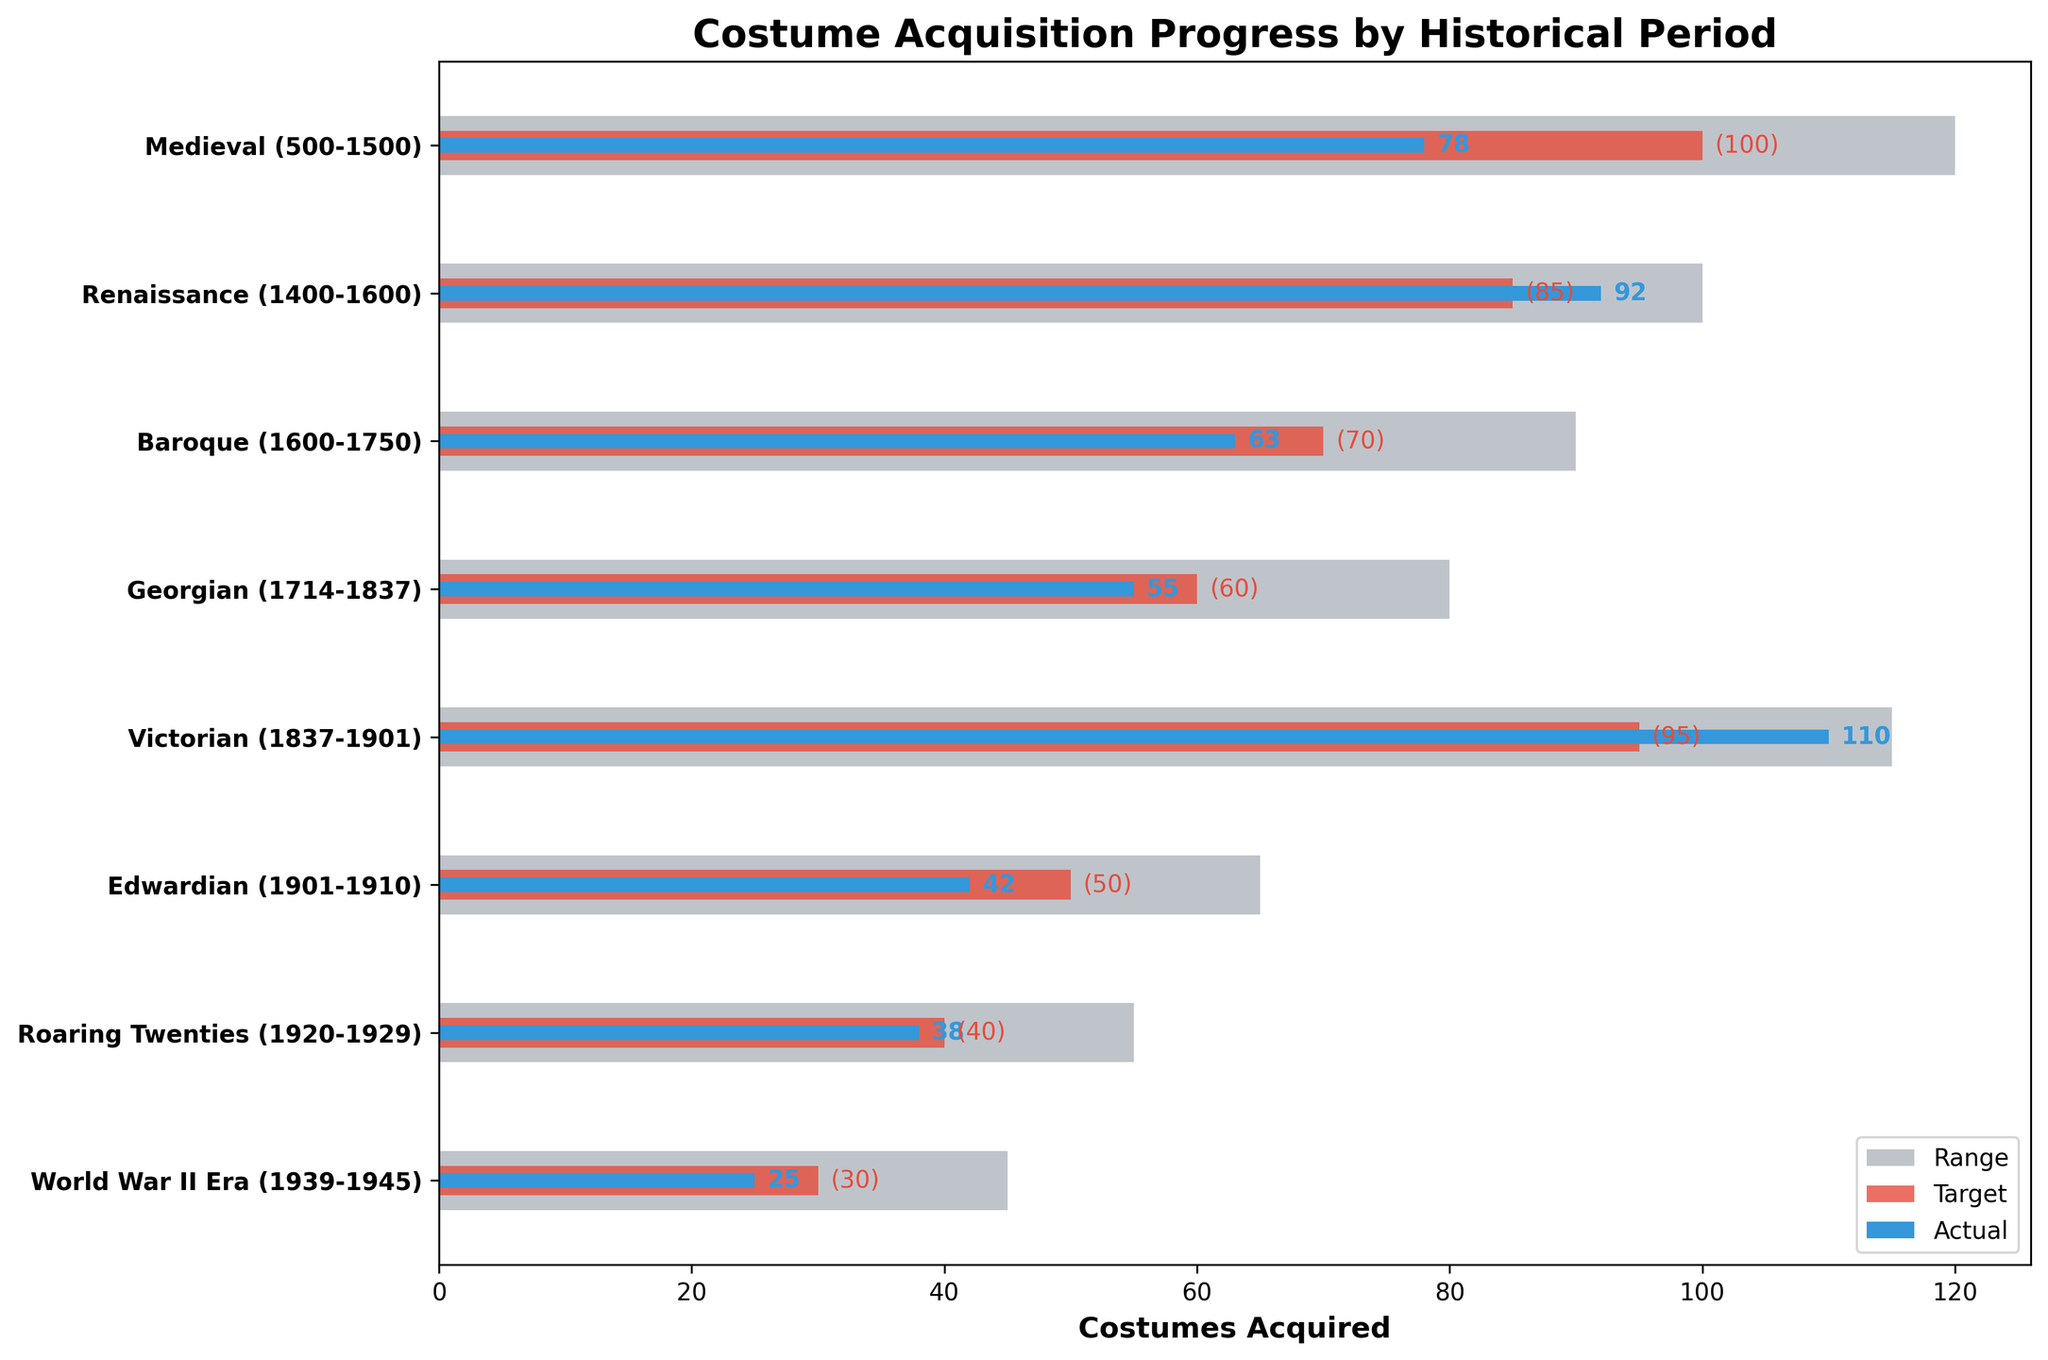What is the title of the figure? The title of the figure is displayed prominently at the top.
Answer: Costume Acquisition Progress by Historical Period What color represents the actual values in the chart? The actual values are represented by a distinct color within each horizontal bar.
Answer: Blue Which historical period has the highest number of actual costumes acquired? Identify the bar with the highest value labeled in blue.
Answer: Victorian How does the actual number of costumes acquired in the Edwardian period compare to its target? Compare the position of the blue bar (actual) and the red bar (target) for the Edwardian period.
Answer: Less than the target By how many costumes did the acquisition of Medieval period costumes fall short of the target? Calculate the difference between the actual value (78) and the target value (100). 100 - 78 = 22
Answer: 22 Which historical periods exceeded their target acquisition numbers? Look for periods where the blue bar extends further than the red bar.
Answer: Renaissance, Victorian What is the range of costume acquisition targets for the Baroque period? Read the minimum and maximum values for the Baroque period's range.
Answer: 0 to 90 How many historical periods met or exceeded their range of targets? Identify periods where the actual values (blue bars) reached or surpassed the end of their range.
Answer: 0 What is the difference in costume acquisition between the period with the lowest actual acquisition and the one with the highest? Identify the periods with the lowest (World War II Era - 25) and highest (Victorian - 110) values and calculate the difference. 110 - 25 = 85
Answer: 85 How many more costumes were acquired in the Roaring Twenties period than in the World War II Era? Subtract the number of costumes in the World War II Era (25) from those in the Roaring Twenties (38). 38 - 25 = 13
Answer: 13 